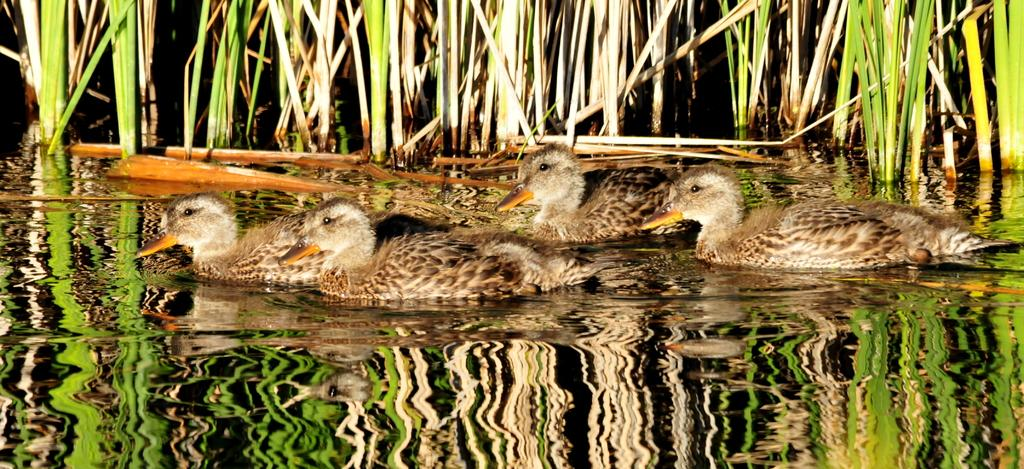What animals are present in the image? There is a group of ducks in the image. Where are the ducks located? The ducks are in the water. What type of vegetation can be seen in the image? There is grass visible in the image. What type of cactus can be seen in the image? There is no cactus present in the image; it features a group of ducks in the water and grass. 